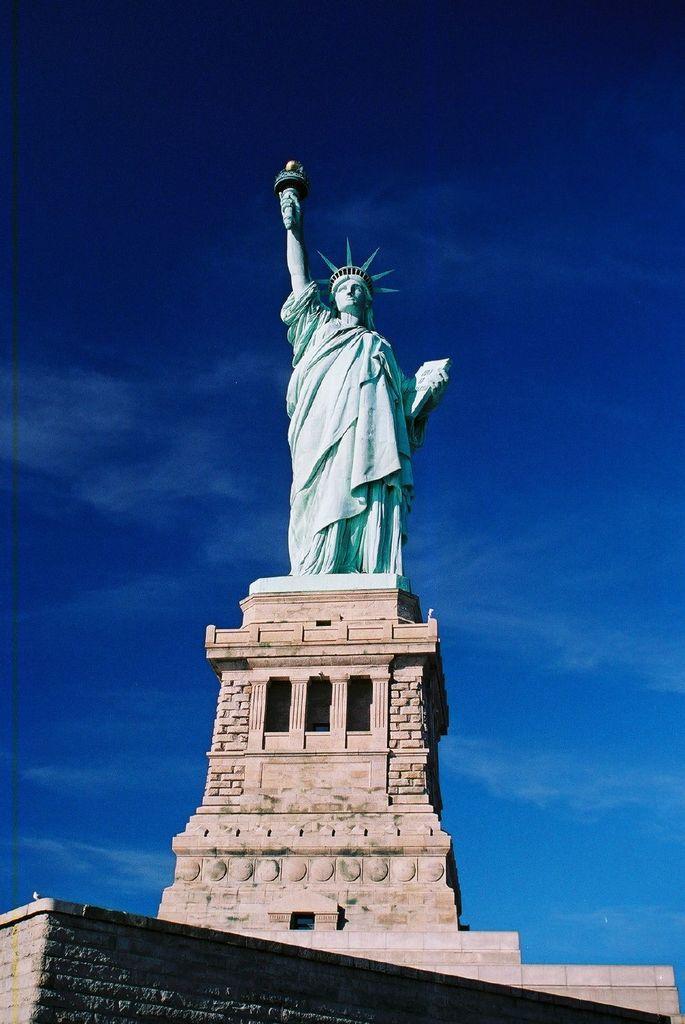Can you describe this image briefly? In this image there is a statue of liberty on the block, there are some clouds in the sky. 